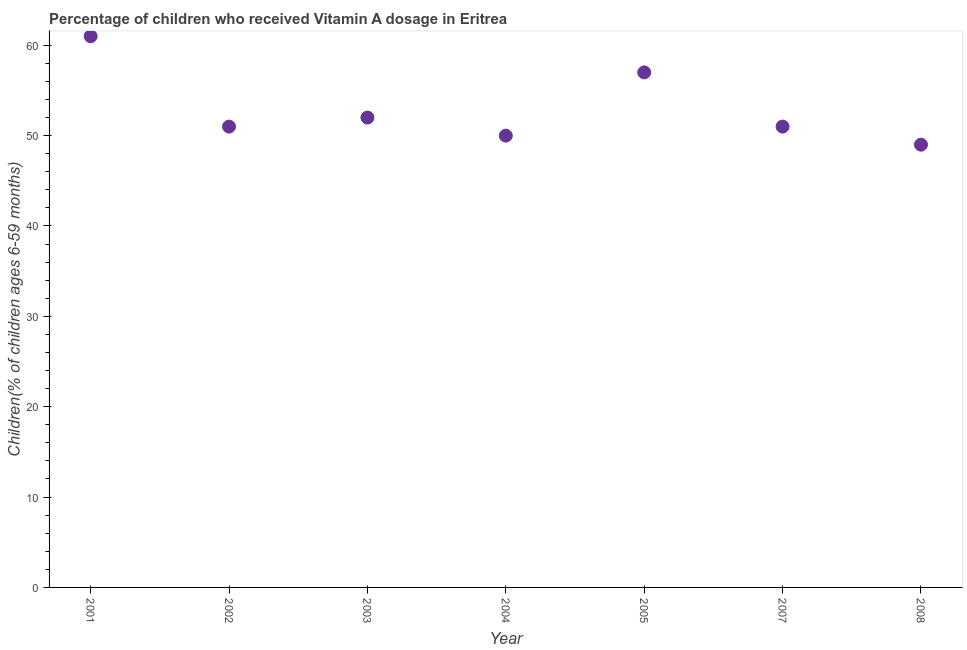Across all years, what is the maximum vitamin a supplementation coverage rate?
Offer a very short reply. 61. In which year was the vitamin a supplementation coverage rate maximum?
Provide a short and direct response. 2001. What is the sum of the vitamin a supplementation coverage rate?
Offer a very short reply. 371. What is the difference between the vitamin a supplementation coverage rate in 2004 and 2008?
Give a very brief answer. 1. What is the average vitamin a supplementation coverage rate per year?
Your answer should be compact. 53. What is the median vitamin a supplementation coverage rate?
Give a very brief answer. 51. In how many years, is the vitamin a supplementation coverage rate greater than 40 %?
Give a very brief answer. 7. What is the ratio of the vitamin a supplementation coverage rate in 2004 to that in 2008?
Your answer should be compact. 1.02. Is the vitamin a supplementation coverage rate in 2004 less than that in 2007?
Offer a very short reply. Yes. Is the difference between the vitamin a supplementation coverage rate in 2003 and 2005 greater than the difference between any two years?
Keep it short and to the point. No. Is the sum of the vitamin a supplementation coverage rate in 2001 and 2005 greater than the maximum vitamin a supplementation coverage rate across all years?
Give a very brief answer. Yes. Does the vitamin a supplementation coverage rate monotonically increase over the years?
Provide a succinct answer. No. How many dotlines are there?
Keep it short and to the point. 1. What is the difference between two consecutive major ticks on the Y-axis?
Offer a terse response. 10. Are the values on the major ticks of Y-axis written in scientific E-notation?
Your response must be concise. No. What is the title of the graph?
Offer a terse response. Percentage of children who received Vitamin A dosage in Eritrea. What is the label or title of the X-axis?
Keep it short and to the point. Year. What is the label or title of the Y-axis?
Give a very brief answer. Children(% of children ages 6-59 months). What is the Children(% of children ages 6-59 months) in 2001?
Keep it short and to the point. 61. What is the Children(% of children ages 6-59 months) in 2002?
Provide a succinct answer. 51. What is the Children(% of children ages 6-59 months) in 2003?
Your answer should be very brief. 52. What is the Children(% of children ages 6-59 months) in 2007?
Ensure brevity in your answer.  51. What is the Children(% of children ages 6-59 months) in 2008?
Ensure brevity in your answer.  49. What is the difference between the Children(% of children ages 6-59 months) in 2001 and 2002?
Make the answer very short. 10. What is the difference between the Children(% of children ages 6-59 months) in 2001 and 2003?
Provide a succinct answer. 9. What is the difference between the Children(% of children ages 6-59 months) in 2001 and 2004?
Provide a succinct answer. 11. What is the difference between the Children(% of children ages 6-59 months) in 2001 and 2005?
Make the answer very short. 4. What is the difference between the Children(% of children ages 6-59 months) in 2002 and 2007?
Offer a very short reply. 0. What is the difference between the Children(% of children ages 6-59 months) in 2003 and 2007?
Ensure brevity in your answer.  1. What is the difference between the Children(% of children ages 6-59 months) in 2003 and 2008?
Give a very brief answer. 3. What is the difference between the Children(% of children ages 6-59 months) in 2004 and 2005?
Your answer should be compact. -7. What is the ratio of the Children(% of children ages 6-59 months) in 2001 to that in 2002?
Offer a terse response. 1.2. What is the ratio of the Children(% of children ages 6-59 months) in 2001 to that in 2003?
Your answer should be very brief. 1.17. What is the ratio of the Children(% of children ages 6-59 months) in 2001 to that in 2004?
Keep it short and to the point. 1.22. What is the ratio of the Children(% of children ages 6-59 months) in 2001 to that in 2005?
Your answer should be very brief. 1.07. What is the ratio of the Children(% of children ages 6-59 months) in 2001 to that in 2007?
Provide a succinct answer. 1.2. What is the ratio of the Children(% of children ages 6-59 months) in 2001 to that in 2008?
Give a very brief answer. 1.25. What is the ratio of the Children(% of children ages 6-59 months) in 2002 to that in 2003?
Give a very brief answer. 0.98. What is the ratio of the Children(% of children ages 6-59 months) in 2002 to that in 2005?
Provide a short and direct response. 0.9. What is the ratio of the Children(% of children ages 6-59 months) in 2002 to that in 2007?
Ensure brevity in your answer.  1. What is the ratio of the Children(% of children ages 6-59 months) in 2002 to that in 2008?
Provide a succinct answer. 1.04. What is the ratio of the Children(% of children ages 6-59 months) in 2003 to that in 2004?
Keep it short and to the point. 1.04. What is the ratio of the Children(% of children ages 6-59 months) in 2003 to that in 2005?
Your answer should be compact. 0.91. What is the ratio of the Children(% of children ages 6-59 months) in 2003 to that in 2008?
Your answer should be compact. 1.06. What is the ratio of the Children(% of children ages 6-59 months) in 2004 to that in 2005?
Your answer should be compact. 0.88. What is the ratio of the Children(% of children ages 6-59 months) in 2004 to that in 2007?
Provide a succinct answer. 0.98. What is the ratio of the Children(% of children ages 6-59 months) in 2004 to that in 2008?
Make the answer very short. 1.02. What is the ratio of the Children(% of children ages 6-59 months) in 2005 to that in 2007?
Your answer should be very brief. 1.12. What is the ratio of the Children(% of children ages 6-59 months) in 2005 to that in 2008?
Your response must be concise. 1.16. What is the ratio of the Children(% of children ages 6-59 months) in 2007 to that in 2008?
Give a very brief answer. 1.04. 